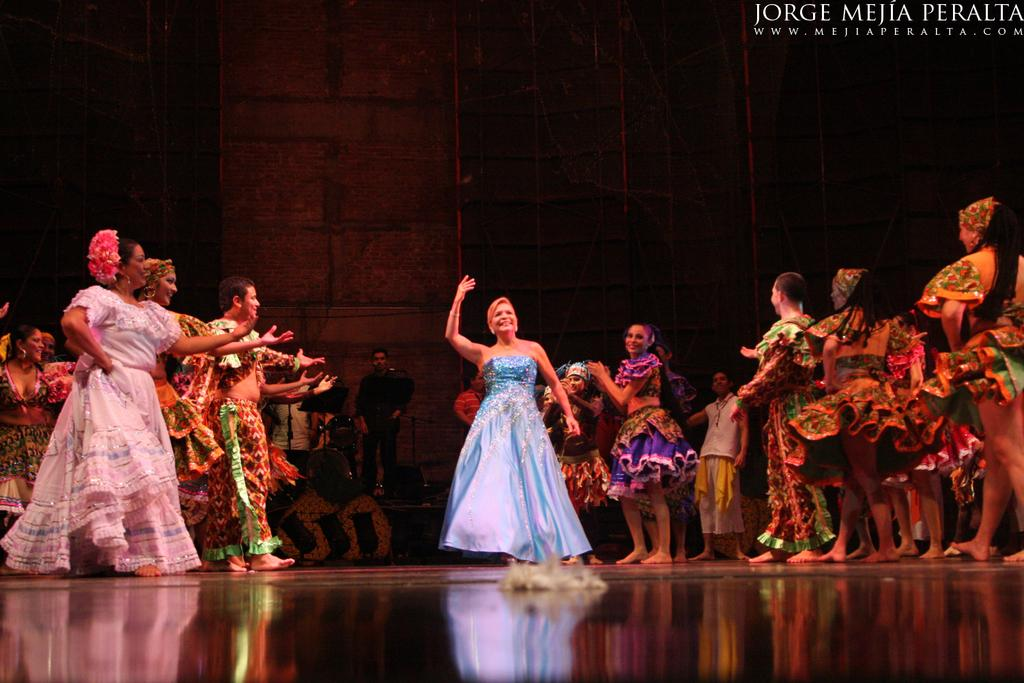How many ladies are in the image? There are many ladies in the image. What are the ladies wearing in the image? The ladies are wearing colorful floral dresses. What are the ladies doing in the image? The ladies are dancing on the floor. What can be seen in the background of the image? There is a wall in the background of the image. What is the position of the man in the image? There is a man standing in front of the wall. What type of road can be seen in the image? There is no road present in the image. How does the hall look in the image? The image does not show a hall; it shows ladies dancing and a man standing in front of a wall. 